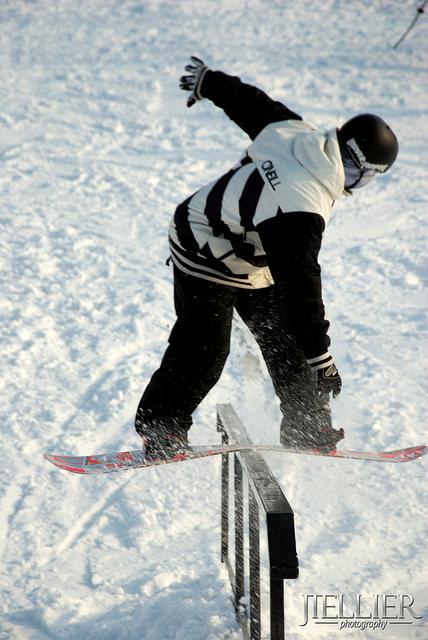Is he wearing black and white?
Be succinct. Yes. What trick is the man doing?
Write a very short answer. Grinding rail. Is he going to fall?
Quick response, please. No. What is the gender of the person in the white jacket?
Be succinct. Male. 